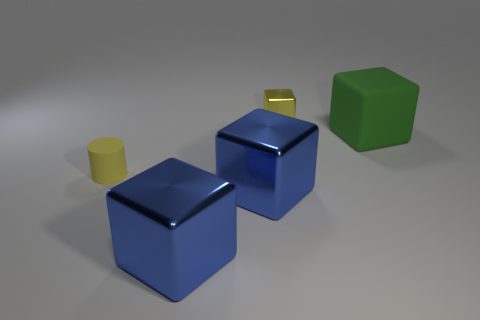Subtract all tiny shiny blocks. How many blocks are left? 3 Subtract 1 cubes. How many cubes are left? 3 Subtract all purple balls. How many blue cubes are left? 2 Subtract all blue blocks. How many blocks are left? 2 Add 5 cubes. How many objects exist? 10 Subtract all gray blocks. Subtract all gray balls. How many blocks are left? 4 Subtract all tiny metallic cylinders. Subtract all big green matte cubes. How many objects are left? 4 Add 3 small rubber cylinders. How many small rubber cylinders are left? 4 Add 1 big green spheres. How many big green spheres exist? 1 Subtract 0 purple cylinders. How many objects are left? 5 